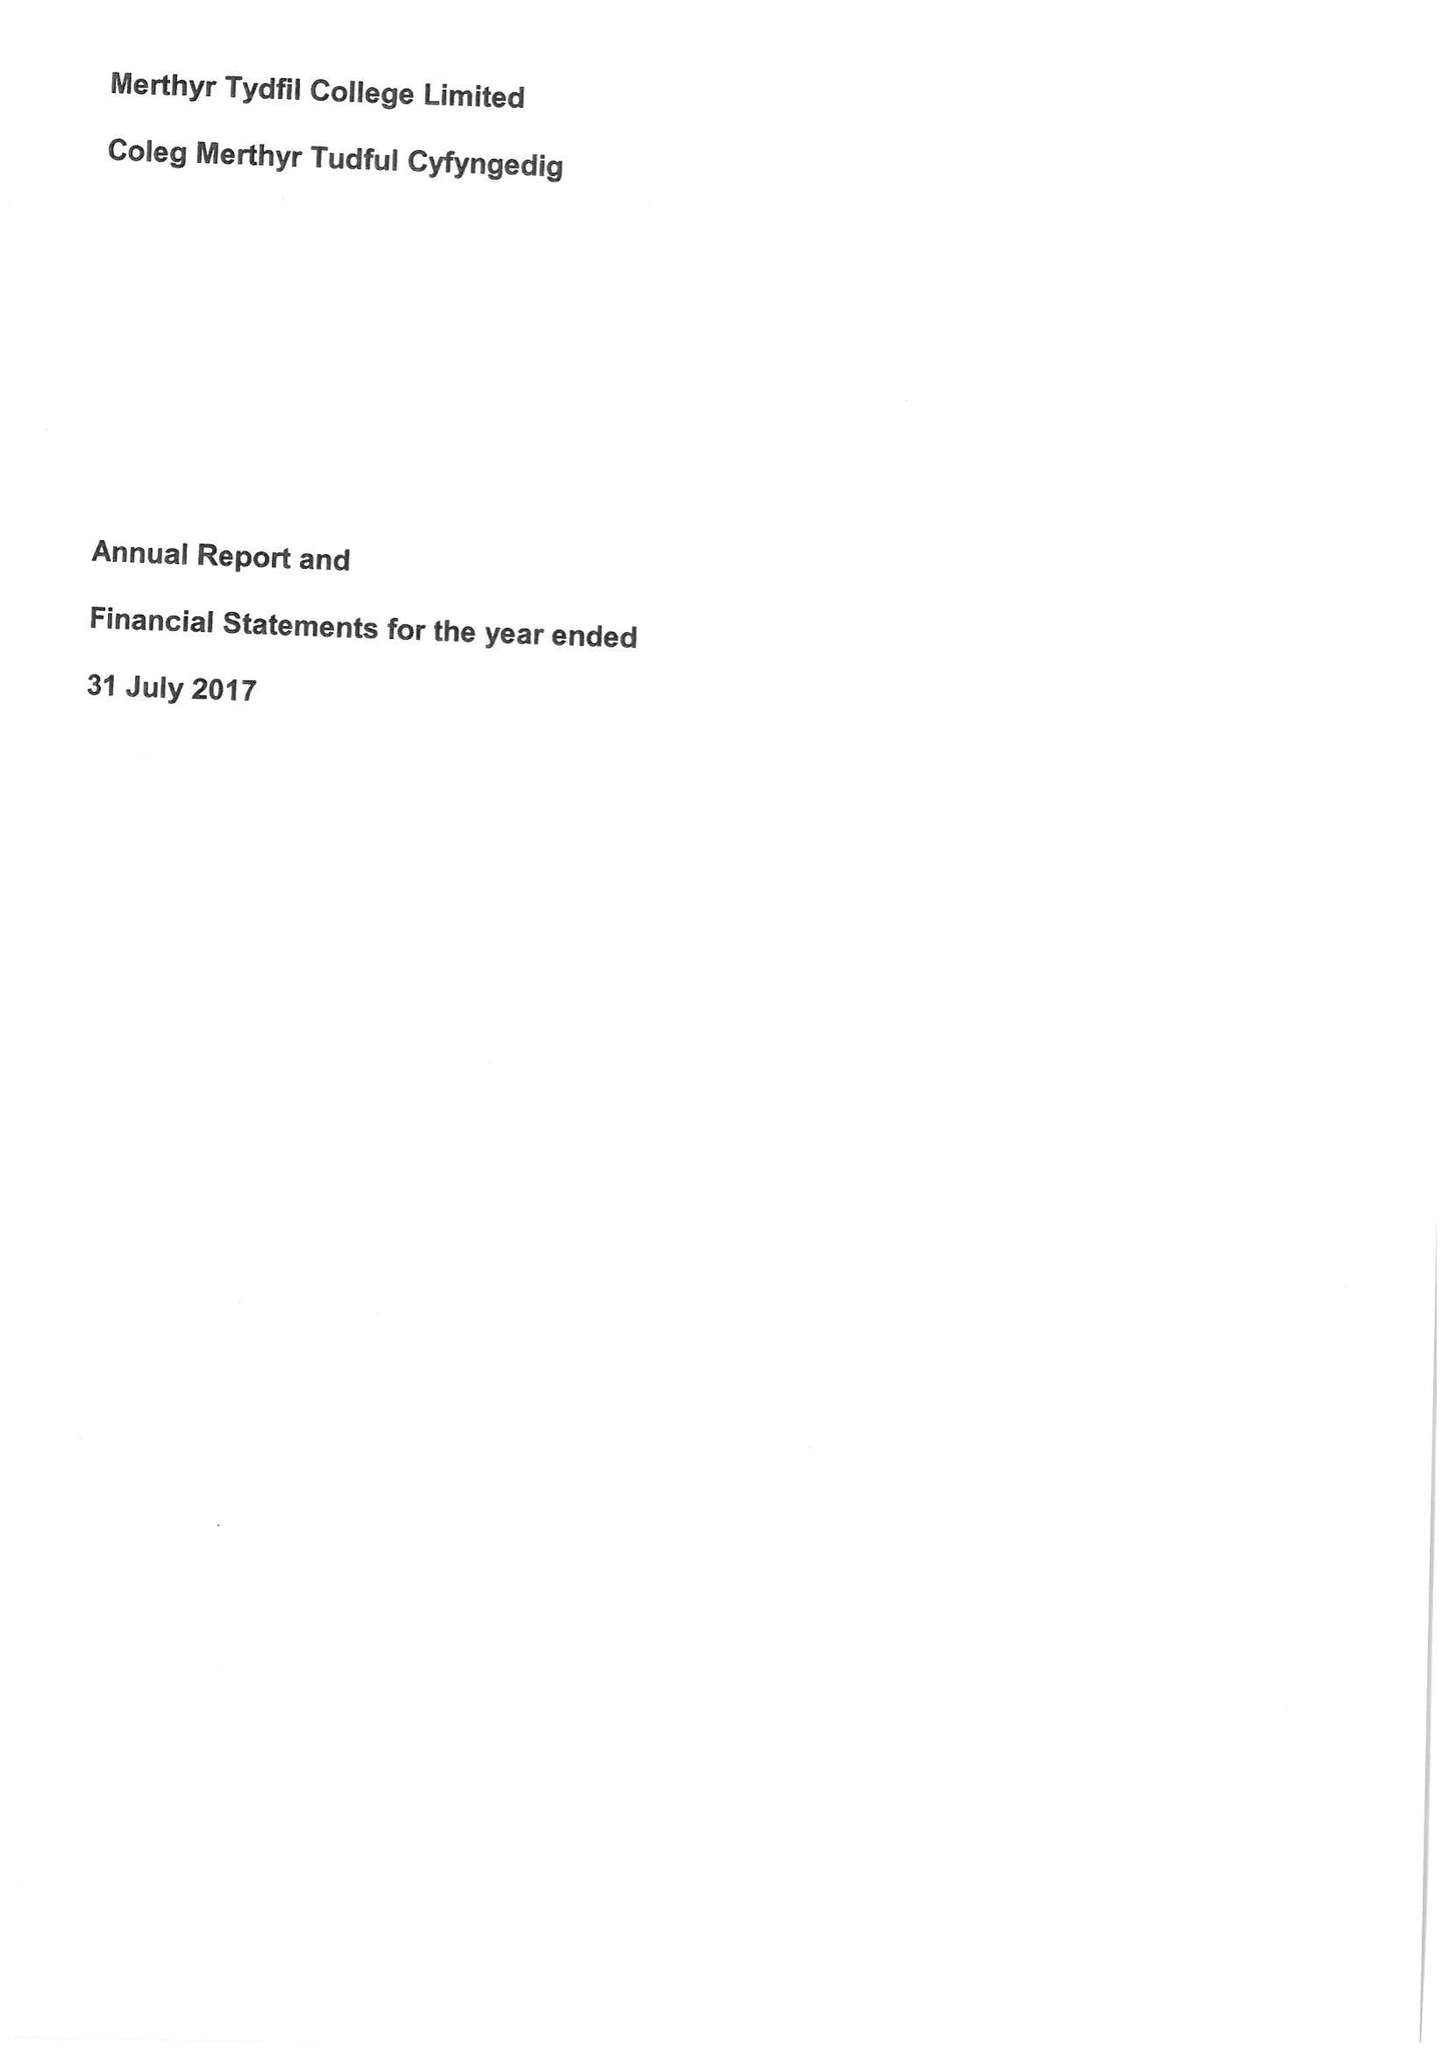What is the value for the charity_number?
Answer the question using a single word or phrase. 1140289 